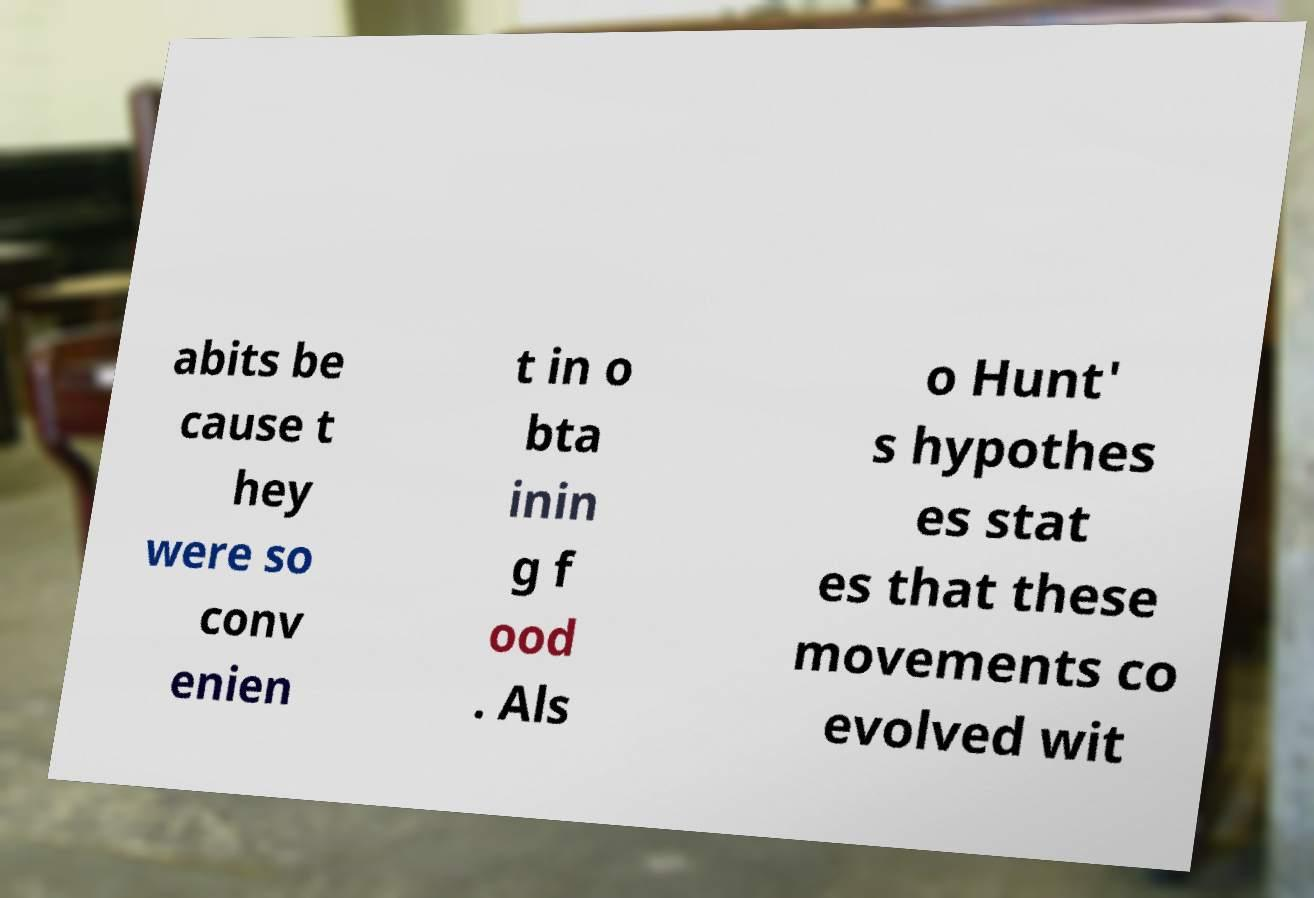Please read and relay the text visible in this image. What does it say? abits be cause t hey were so conv enien t in o bta inin g f ood . Als o Hunt' s hypothes es stat es that these movements co evolved wit 